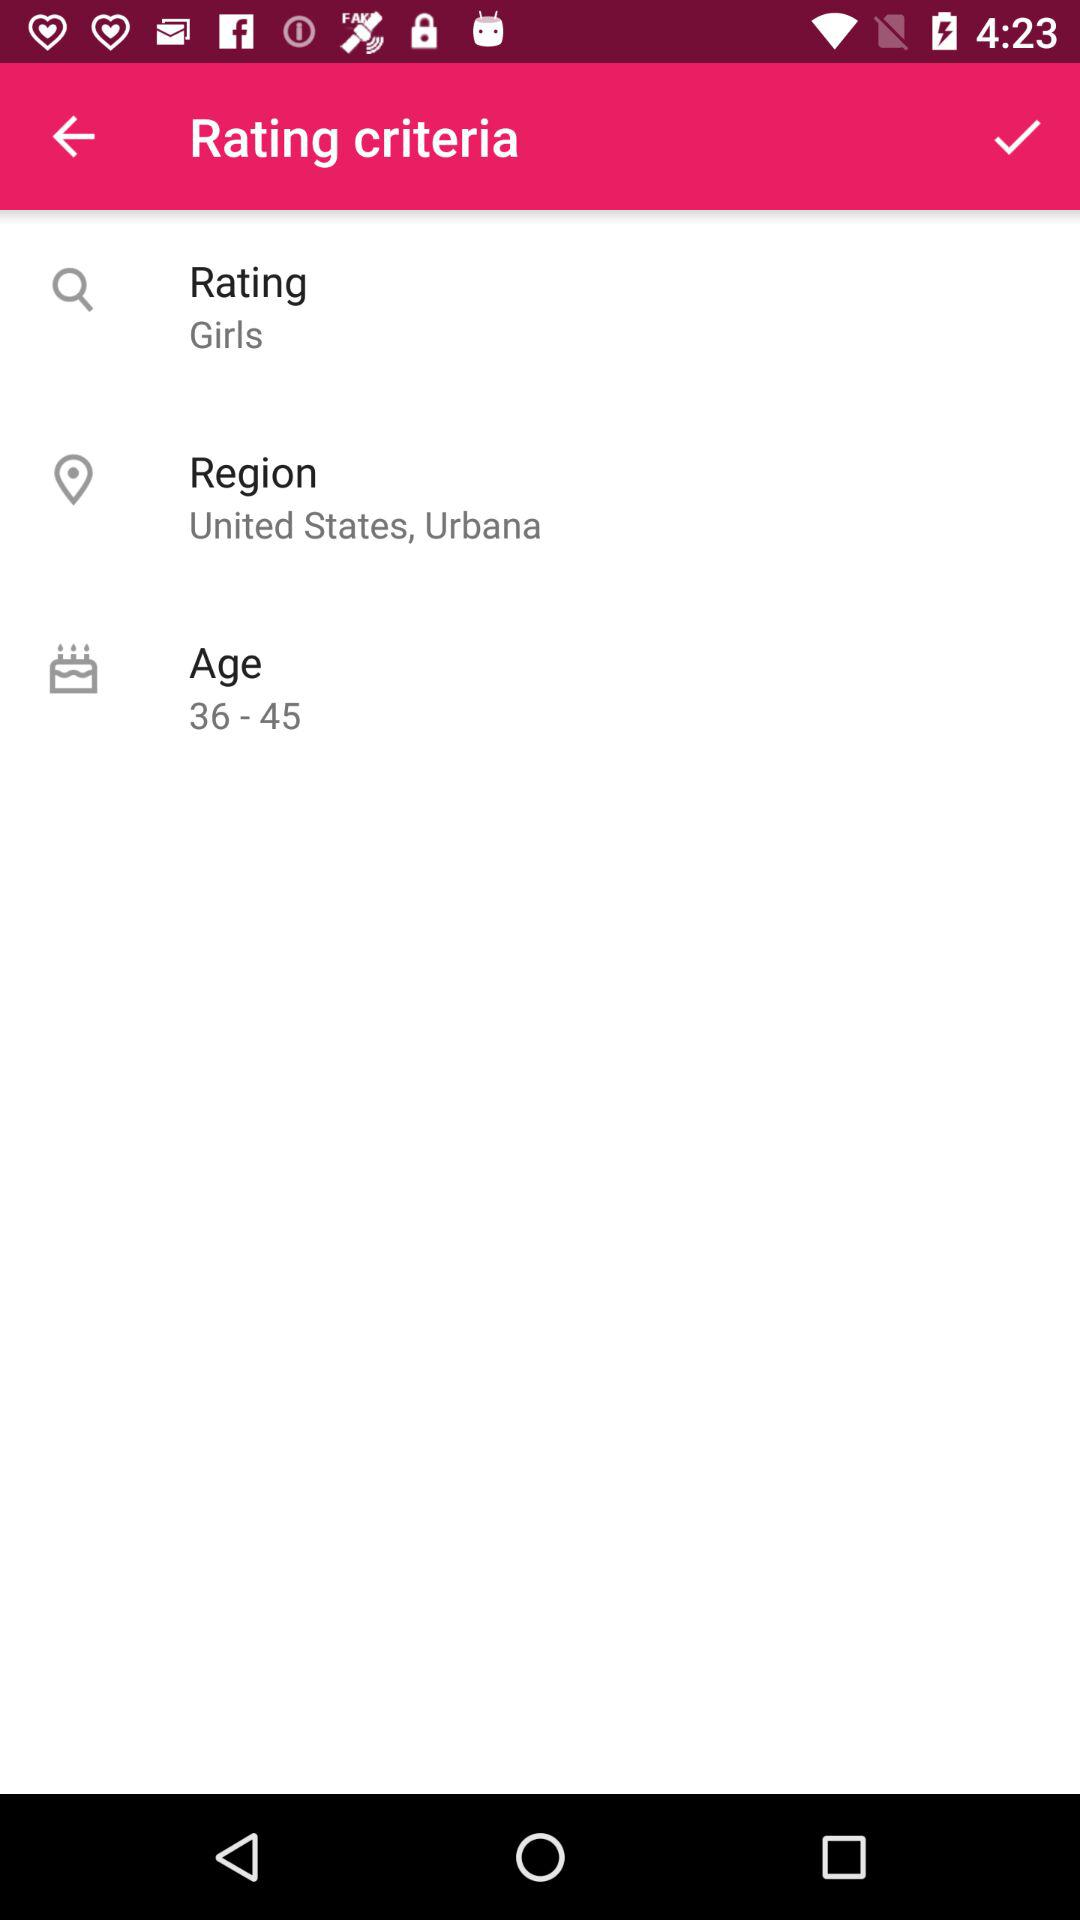How many rating criteria are there?
Answer the question using a single word or phrase. 3 